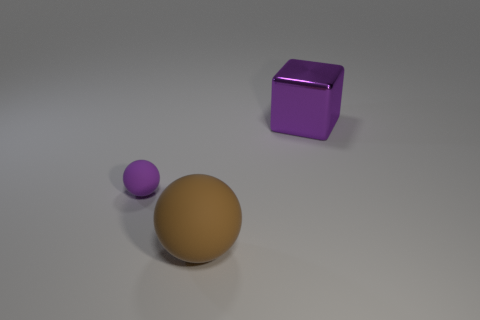Is the color of the big metallic block the same as the tiny ball?
Make the answer very short. Yes. Are there an equal number of brown objects that are behind the small object and large brown matte objects that are behind the big metallic block?
Your answer should be compact. Yes. Does the large thing that is in front of the metal object have the same material as the ball behind the large brown rubber thing?
Ensure brevity in your answer.  Yes. What number of other objects are the same size as the metal cube?
Your response must be concise. 1. How many objects are large gray rubber balls or objects behind the tiny matte sphere?
Give a very brief answer. 1. Is the number of metal things on the left side of the purple metallic block the same as the number of gray shiny objects?
Give a very brief answer. Yes. The brown object that is the same material as the purple ball is what shape?
Provide a succinct answer. Sphere. Is there a big object that has the same color as the tiny object?
Your answer should be very brief. Yes. What number of rubber things are big things or red cylinders?
Your answer should be very brief. 1. How many rubber objects are on the right side of the rubber sphere that is on the left side of the large brown rubber sphere?
Keep it short and to the point. 1. 